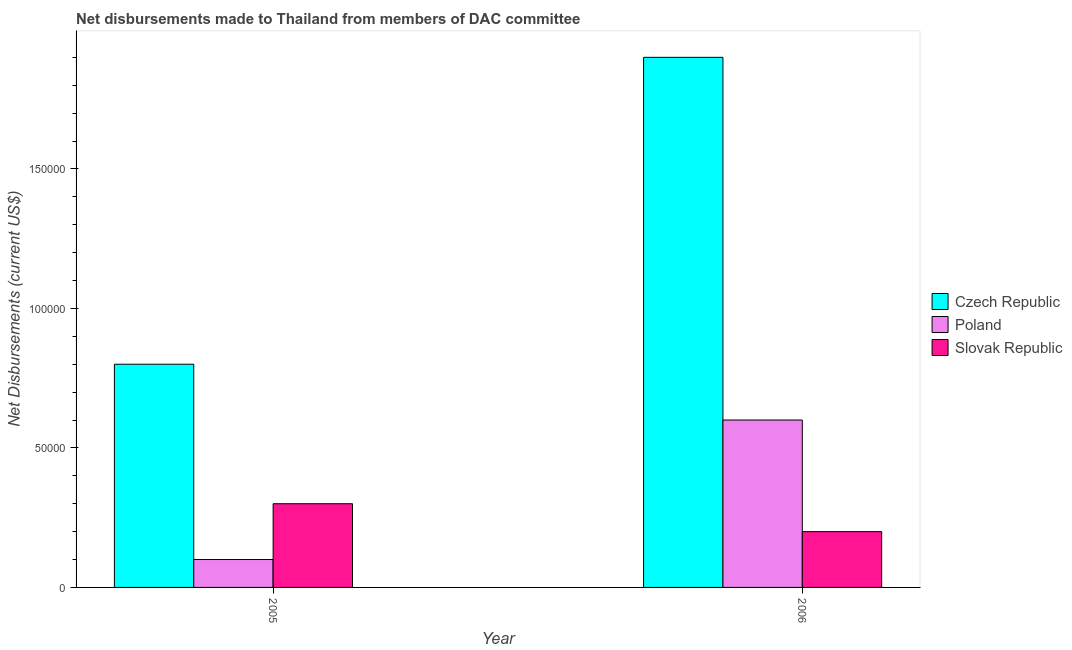How many groups of bars are there?
Your answer should be compact. 2. Are the number of bars per tick equal to the number of legend labels?
Offer a very short reply. Yes. How many bars are there on the 2nd tick from the right?
Give a very brief answer. 3. In how many cases, is the number of bars for a given year not equal to the number of legend labels?
Offer a very short reply. 0. What is the net disbursements made by slovak republic in 2006?
Give a very brief answer. 2.00e+04. Across all years, what is the maximum net disbursements made by slovak republic?
Ensure brevity in your answer.  3.00e+04. Across all years, what is the minimum net disbursements made by poland?
Provide a short and direct response. 10000. What is the total net disbursements made by slovak republic in the graph?
Your response must be concise. 5.00e+04. What is the difference between the net disbursements made by slovak republic in 2005 and that in 2006?
Provide a short and direct response. 10000. What is the difference between the net disbursements made by czech republic in 2006 and the net disbursements made by slovak republic in 2005?
Provide a short and direct response. 1.10e+05. What is the average net disbursements made by czech republic per year?
Provide a succinct answer. 1.35e+05. In the year 2005, what is the difference between the net disbursements made by slovak republic and net disbursements made by czech republic?
Offer a very short reply. 0. What is the ratio of the net disbursements made by poland in 2005 to that in 2006?
Offer a terse response. 0.17. What does the 3rd bar from the right in 2005 represents?
Keep it short and to the point. Czech Republic. How many bars are there?
Your answer should be compact. 6. What is the difference between two consecutive major ticks on the Y-axis?
Your answer should be compact. 5.00e+04. Does the graph contain grids?
Provide a short and direct response. No. What is the title of the graph?
Give a very brief answer. Net disbursements made to Thailand from members of DAC committee. Does "Methane" appear as one of the legend labels in the graph?
Your answer should be compact. No. What is the label or title of the Y-axis?
Provide a short and direct response. Net Disbursements (current US$). What is the Net Disbursements (current US$) of Slovak Republic in 2006?
Your answer should be very brief. 2.00e+04. Across all years, what is the maximum Net Disbursements (current US$) of Slovak Republic?
Ensure brevity in your answer.  3.00e+04. Across all years, what is the minimum Net Disbursements (current US$) of Czech Republic?
Give a very brief answer. 8.00e+04. Across all years, what is the minimum Net Disbursements (current US$) in Slovak Republic?
Your answer should be very brief. 2.00e+04. What is the total Net Disbursements (current US$) of Czech Republic in the graph?
Your answer should be very brief. 2.70e+05. What is the total Net Disbursements (current US$) in Poland in the graph?
Ensure brevity in your answer.  7.00e+04. What is the difference between the Net Disbursements (current US$) of Czech Republic in 2005 and that in 2006?
Make the answer very short. -1.10e+05. What is the difference between the Net Disbursements (current US$) of Slovak Republic in 2005 and that in 2006?
Offer a terse response. 10000. What is the difference between the Net Disbursements (current US$) in Czech Republic in 2005 and the Net Disbursements (current US$) in Poland in 2006?
Provide a short and direct response. 2.00e+04. What is the difference between the Net Disbursements (current US$) of Poland in 2005 and the Net Disbursements (current US$) of Slovak Republic in 2006?
Your answer should be very brief. -10000. What is the average Net Disbursements (current US$) of Czech Republic per year?
Ensure brevity in your answer.  1.35e+05. What is the average Net Disbursements (current US$) of Poland per year?
Give a very brief answer. 3.50e+04. What is the average Net Disbursements (current US$) in Slovak Republic per year?
Your response must be concise. 2.50e+04. In the year 2005, what is the difference between the Net Disbursements (current US$) in Czech Republic and Net Disbursements (current US$) in Slovak Republic?
Your answer should be very brief. 5.00e+04. In the year 2006, what is the difference between the Net Disbursements (current US$) in Czech Republic and Net Disbursements (current US$) in Poland?
Ensure brevity in your answer.  1.30e+05. In the year 2006, what is the difference between the Net Disbursements (current US$) in Czech Republic and Net Disbursements (current US$) in Slovak Republic?
Ensure brevity in your answer.  1.70e+05. In the year 2006, what is the difference between the Net Disbursements (current US$) in Poland and Net Disbursements (current US$) in Slovak Republic?
Your response must be concise. 4.00e+04. What is the ratio of the Net Disbursements (current US$) of Czech Republic in 2005 to that in 2006?
Offer a terse response. 0.42. What is the difference between the highest and the second highest Net Disbursements (current US$) in Poland?
Make the answer very short. 5.00e+04. What is the difference between the highest and the second highest Net Disbursements (current US$) in Slovak Republic?
Give a very brief answer. 10000. What is the difference between the highest and the lowest Net Disbursements (current US$) in Czech Republic?
Make the answer very short. 1.10e+05. What is the difference between the highest and the lowest Net Disbursements (current US$) of Slovak Republic?
Offer a terse response. 10000. 